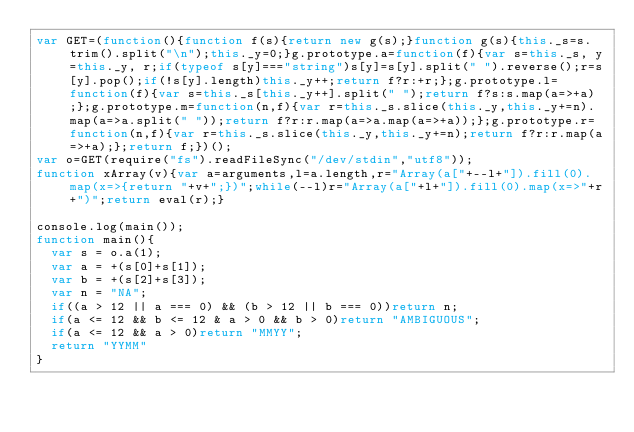<code> <loc_0><loc_0><loc_500><loc_500><_JavaScript_>var GET=(function(){function f(s){return new g(s);}function g(s){this._s=s.trim().split("\n");this._y=0;}g.prototype.a=function(f){var s=this._s, y=this._y, r;if(typeof s[y]==="string")s[y]=s[y].split(" ").reverse();r=s[y].pop();if(!s[y].length)this._y++;return f?r:+r;};g.prototype.l=function(f){var s=this._s[this._y++].split(" ");return f?s:s.map(a=>+a);};g.prototype.m=function(n,f){var r=this._s.slice(this._y,this._y+=n).map(a=>a.split(" "));return f?r:r.map(a=>a.map(a=>+a));};g.prototype.r=function(n,f){var r=this._s.slice(this._y,this._y+=n);return f?r:r.map(a=>+a);};return f;})();
var o=GET(require("fs").readFileSync("/dev/stdin","utf8"));
function xArray(v){var a=arguments,l=a.length,r="Array(a["+--l+"]).fill(0).map(x=>{return "+v+";})";while(--l)r="Array(a["+l+"]).fill(0).map(x=>"+r+")";return eval(r);}

console.log(main());
function main(){
  var s = o.a(1);
  var a = +(s[0]+s[1]);
  var b = +(s[2]+s[3]);
  var n = "NA";
  if((a > 12 || a === 0) && (b > 12 || b === 0))return n;
  if(a <= 12 && b <= 12 & a > 0 && b > 0)return "AMBIGUOUS";
  if(a <= 12 && a > 0)return "MMYY";
  return "YYMM"
}</code> 